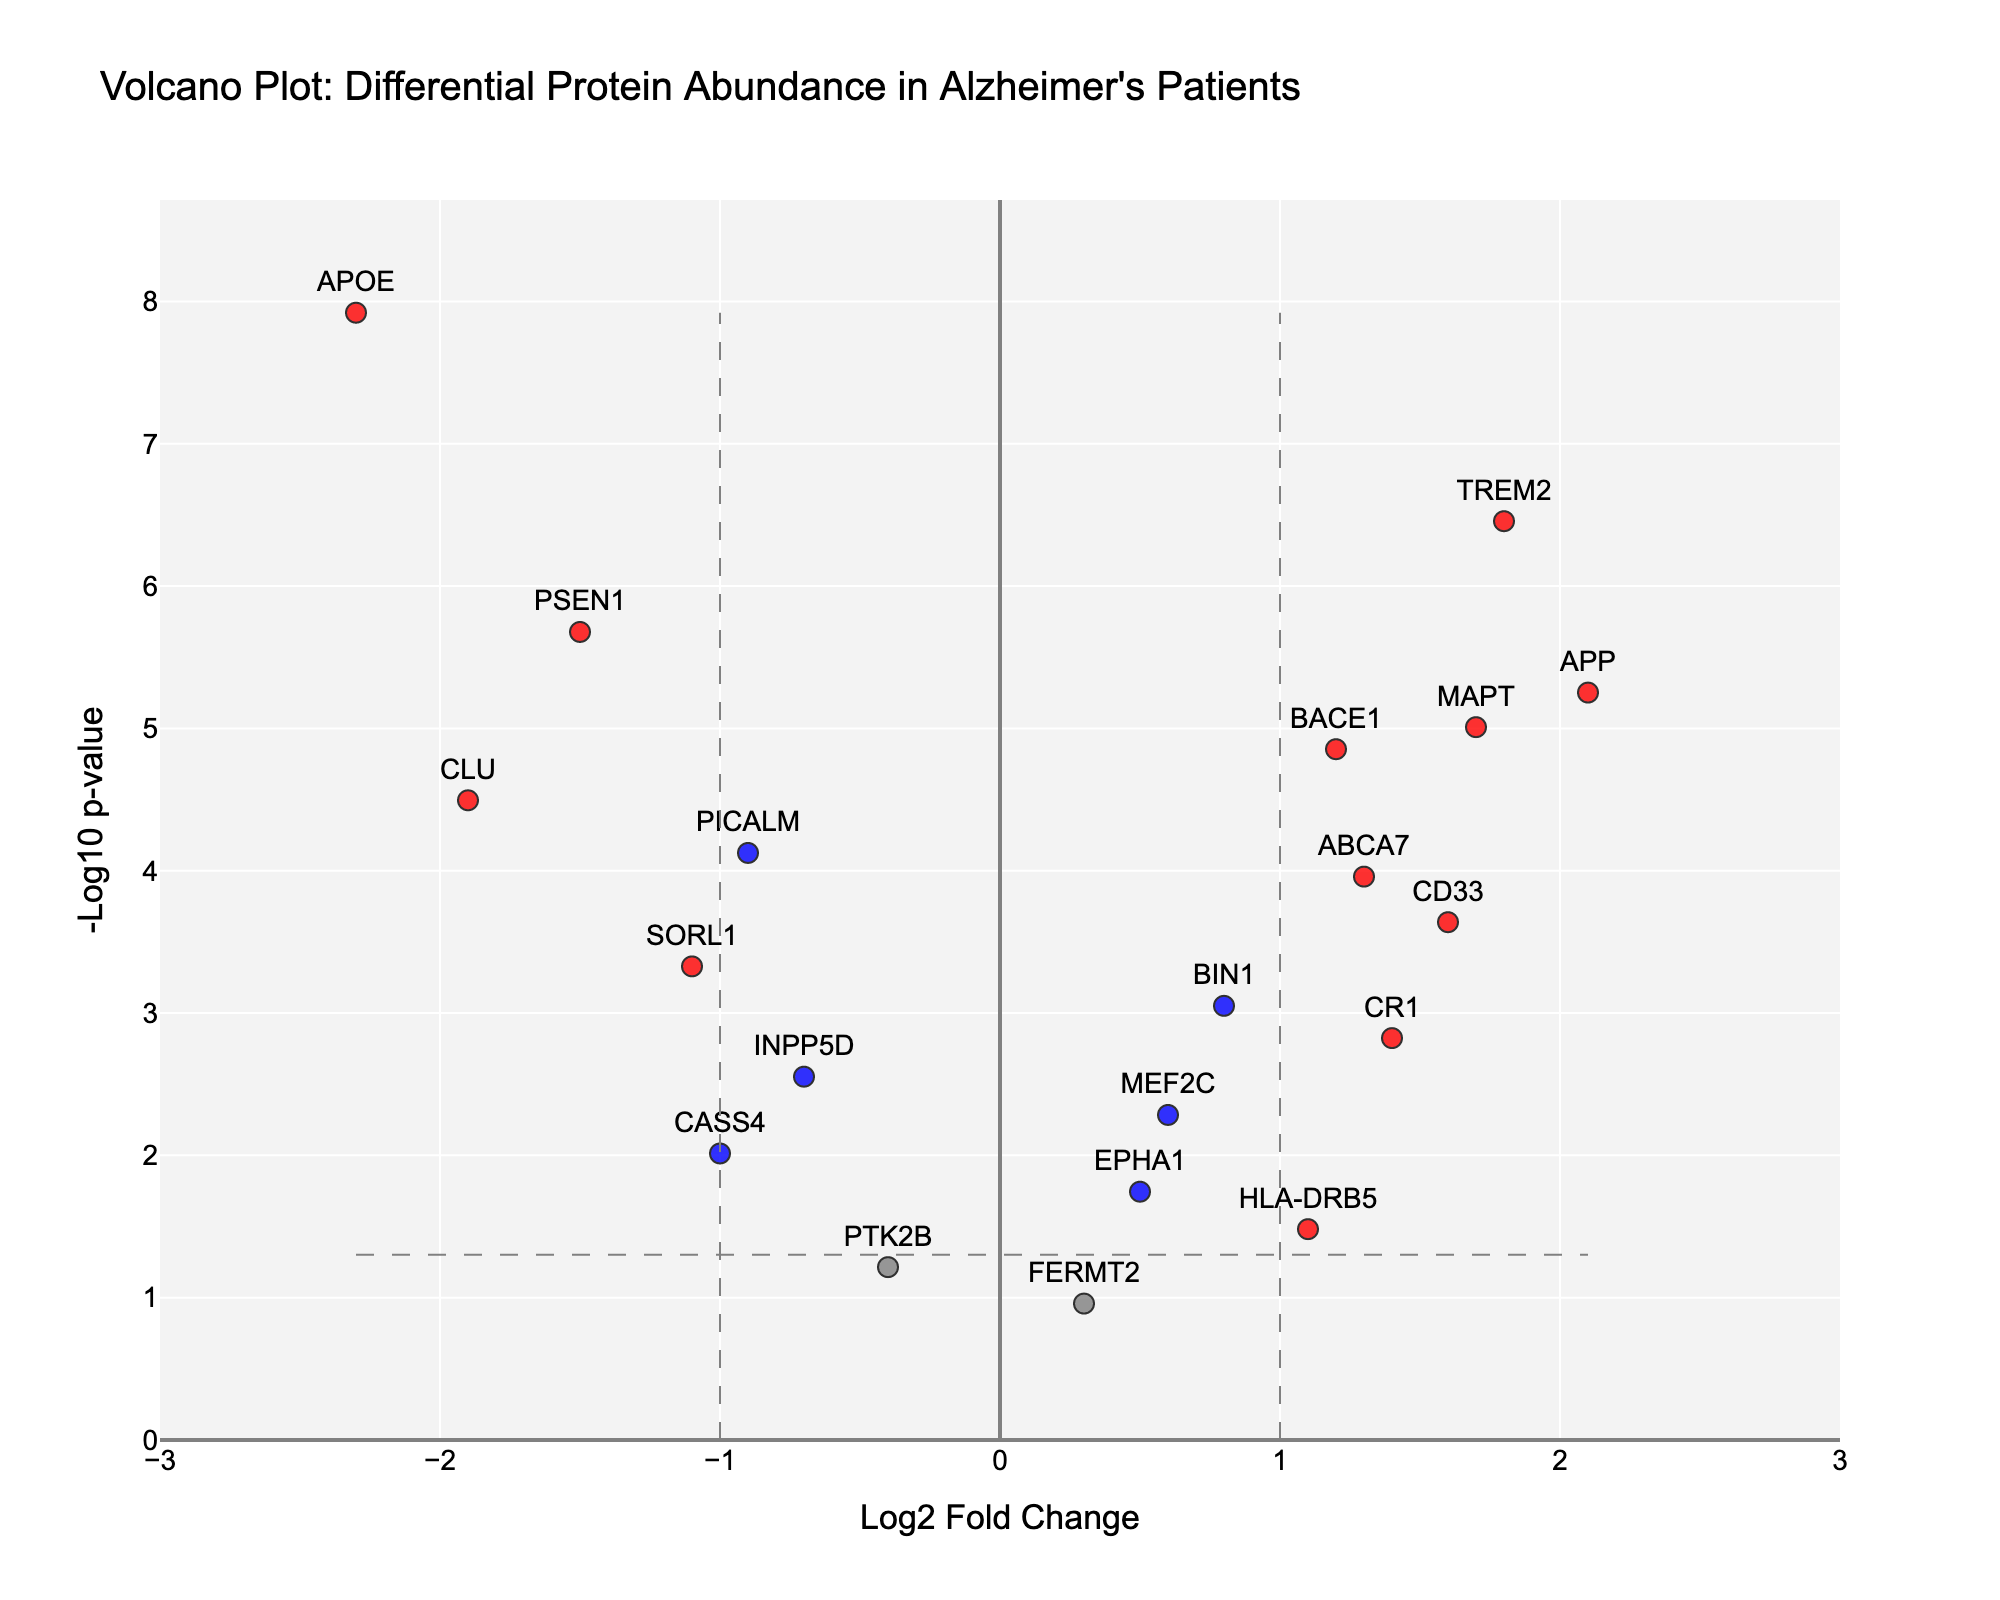What's the title of the figure? The title is displayed at the top of the plot, which provides an overview of the plot's content.
Answer: Volcano Plot: Differential Protein Abundance in Alzheimer's Patients What does the x-axis represent? The label given to the x-axis indicates that it represents the "Log2 Fold Change".
Answer: Log2 Fold Change What does the y-axis represent? The label given to the y-axis indicates that it represents the "-Log10 p-value".
Answer: -Log10 p-value How many proteins have a Log2 Fold Change greater than 1? By examining the plot, we count the number of data points (markers) that are positioned to the right of the Log2FC = 1 threshold line.
Answer: 7 Which proteins are highlighted in red, and what does red signify? Red color indicates proteins with an absolute Log2 Fold Change greater than 1 and a p-value less than 0.05. The identified proteins in red include APOE, TREM2, APP, MAPT, CLU.
Answer: APOE, TREM2, APP, MAPT, CLU Which protein has the highest Log2 Fold Change, and what is that value? By locating the rightmost point on the x-axis, we find the protein with the highest Log2 Fold Change. This is APP with a Log2FC of 2.1.
Answer: APP, 2.1 Which proteins have a p-value less than 1e-05? By identifying points with a -Log10 p-value greater than 5 on the y-axis, the proteins are APOE, TREM2, PSEN1, APP, and MAPT.
Answer: APOE, TREM2, PSEN1, APP, MAPT What is the Log2 Fold Change and p-value of BACE1? Find the marker labeled "BACE1", note its x (Log2FC) and y (-Log10 p-value) coordinates. The coordinates are Log2FC: 1.2 and p-value: 1.4e-05.
Answer: Log2 Fold Change: 1.2, p-value: 1.4e-05 Are there any proteins with a Log2 Fold Change between -1 and 0 and a significant p-value (less than 0.05)? By examining the gray area within the range of -1 to 0 on the x-axis and above the -Log10(p_threshold) line on the y-axis, we find PICALM, INPP5D, CASS4.
Answer: PICALM, INPP5D, CASS4 What color represents the proteins with a non-significant p-value but significant Log2 Fold Change and which proteins are these? Green color indicates proteins with an absolute Log2 Fold Change greater than 1 and a p-value greater than or equal to 0.05. No proteins fit this category.
Answer: None 